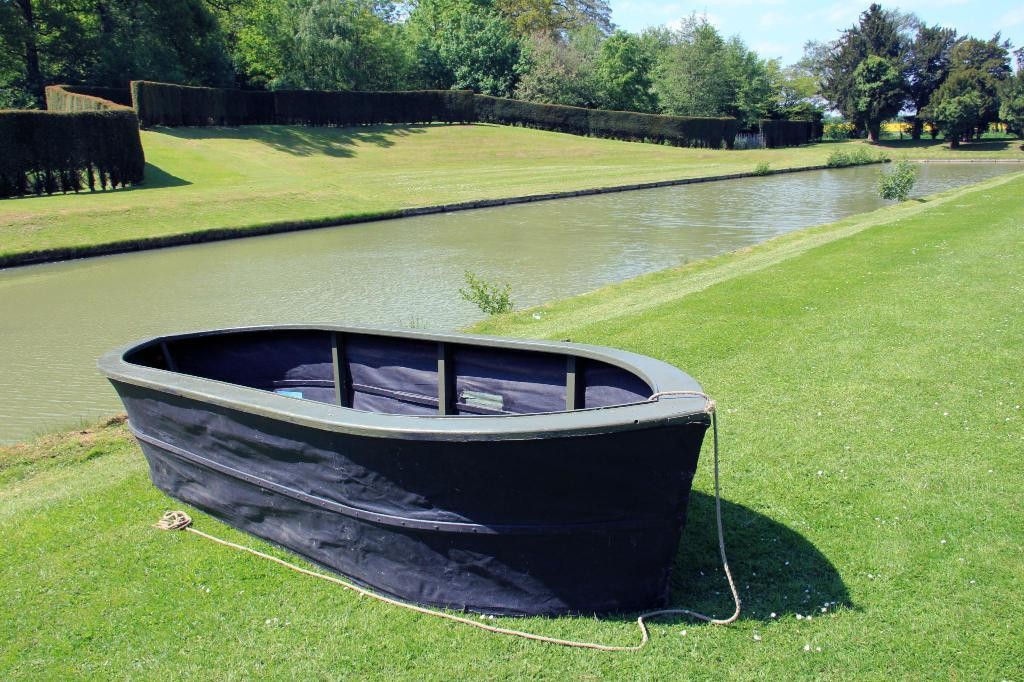What is the main subject of the image? The main subject of the image is a boat. What is attached to the boat? The boat has a rope attached to it. Where is the boat located? The boat is on a grass path. What can be seen behind the boat? There is water visible behind the boat, followed by a hedge, trees, and the sky. What type of vegetation is present in the image? Plants are visible in the image. What type of line is being used to paint the can on the canvas in the image? There is no line, can, or canvas present in the image. 